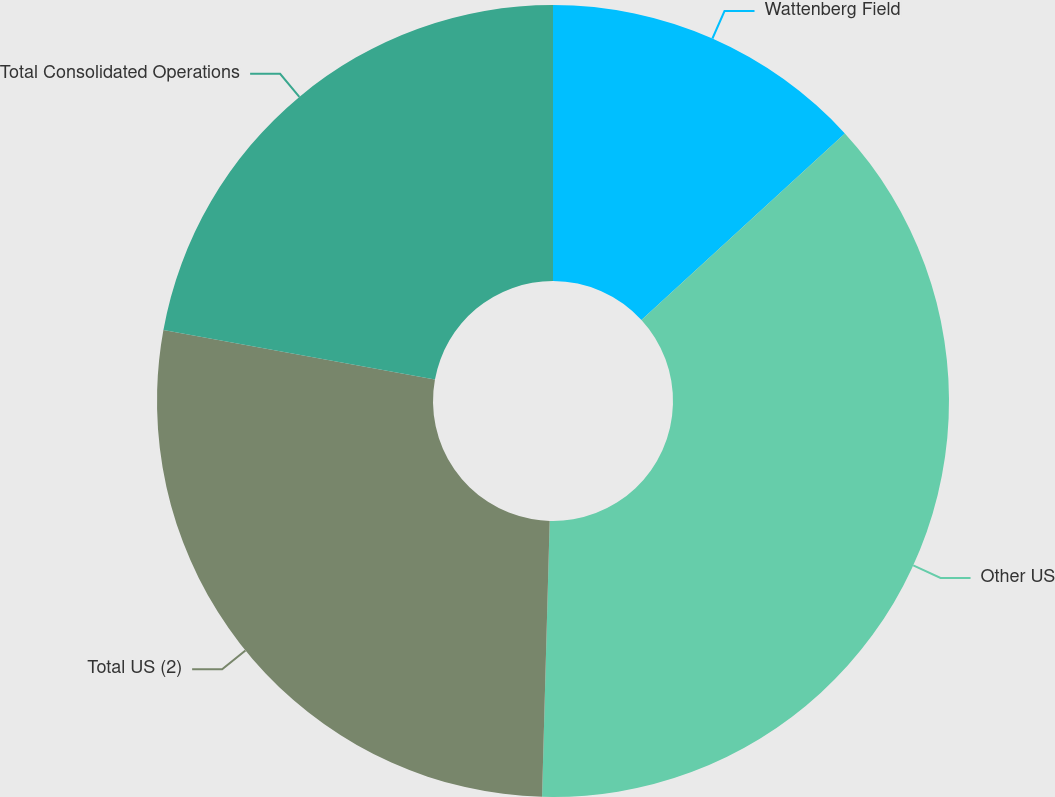Convert chart to OTSL. <chart><loc_0><loc_0><loc_500><loc_500><pie_chart><fcel>Wattenberg Field<fcel>Other US<fcel>Total US (2)<fcel>Total Consolidated Operations<nl><fcel>13.19%<fcel>37.25%<fcel>27.43%<fcel>22.13%<nl></chart> 